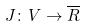Convert formula to latex. <formula><loc_0><loc_0><loc_500><loc_500>J \colon V \rightarrow \overline { R }</formula> 